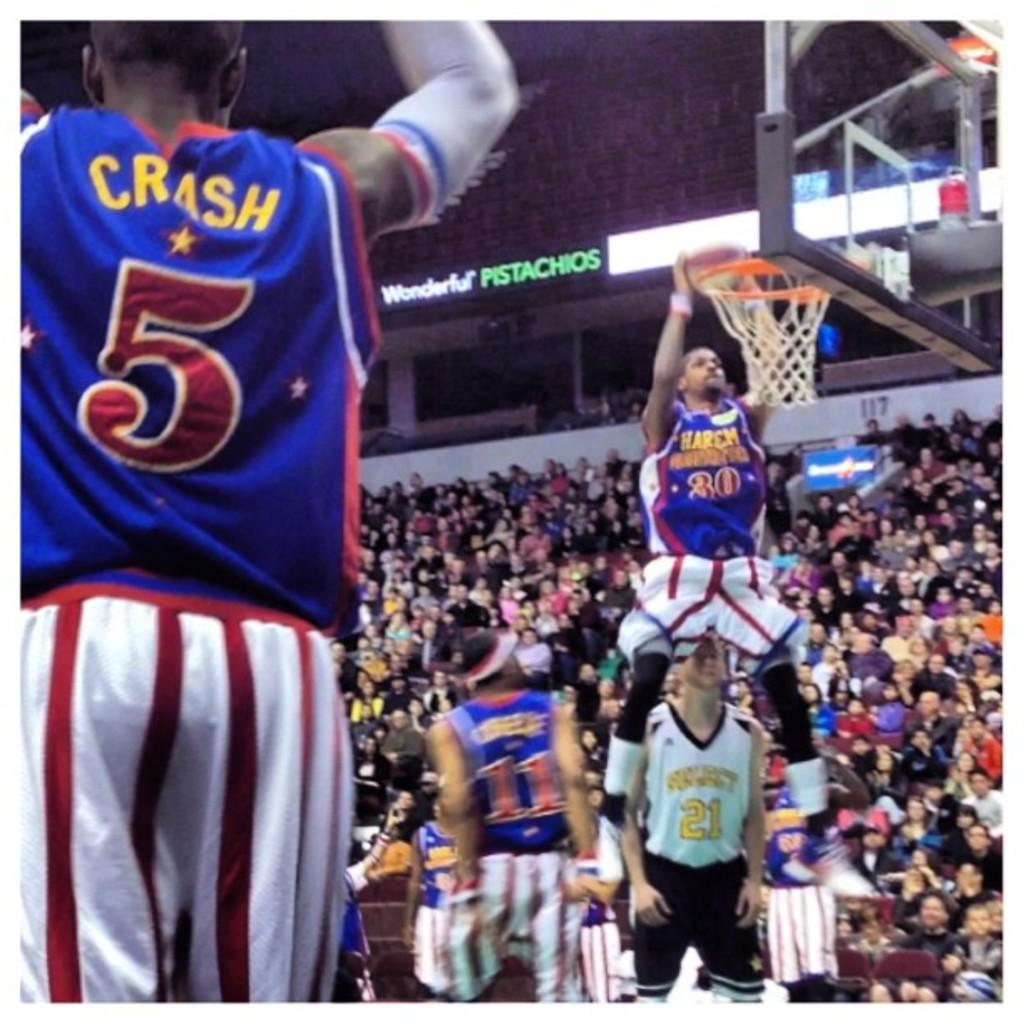Provide a one-sentence caption for the provided image. a basketball game going on, with player CRASH 5 up front, and Wonderful Pistashios on the banner ad. 